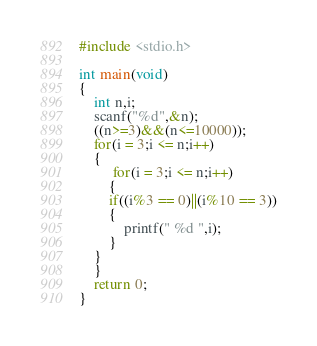Convert code to text. <code><loc_0><loc_0><loc_500><loc_500><_C_>#include <stdio.h>

int main(void)
{
	int n,i;
    scanf("%d",&n);
    ((n>=3)&&(n<=10000));
    for(i = 3;i <= n;i++)
	{
		 for(i = 3;i <= n;i++)
		{
		if((i%3 == 0)||(i%10 == 3))
		{
			printf(" %d ",i);
		}
	}
	}
	return 0;
}</code> 